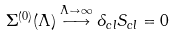Convert formula to latex. <formula><loc_0><loc_0><loc_500><loc_500>\Sigma ^ { ( 0 ) } ( \Lambda ) \stackrel { \Lambda \to \infty } { \longrightarrow } \delta _ { c l } S _ { c l } = 0</formula> 